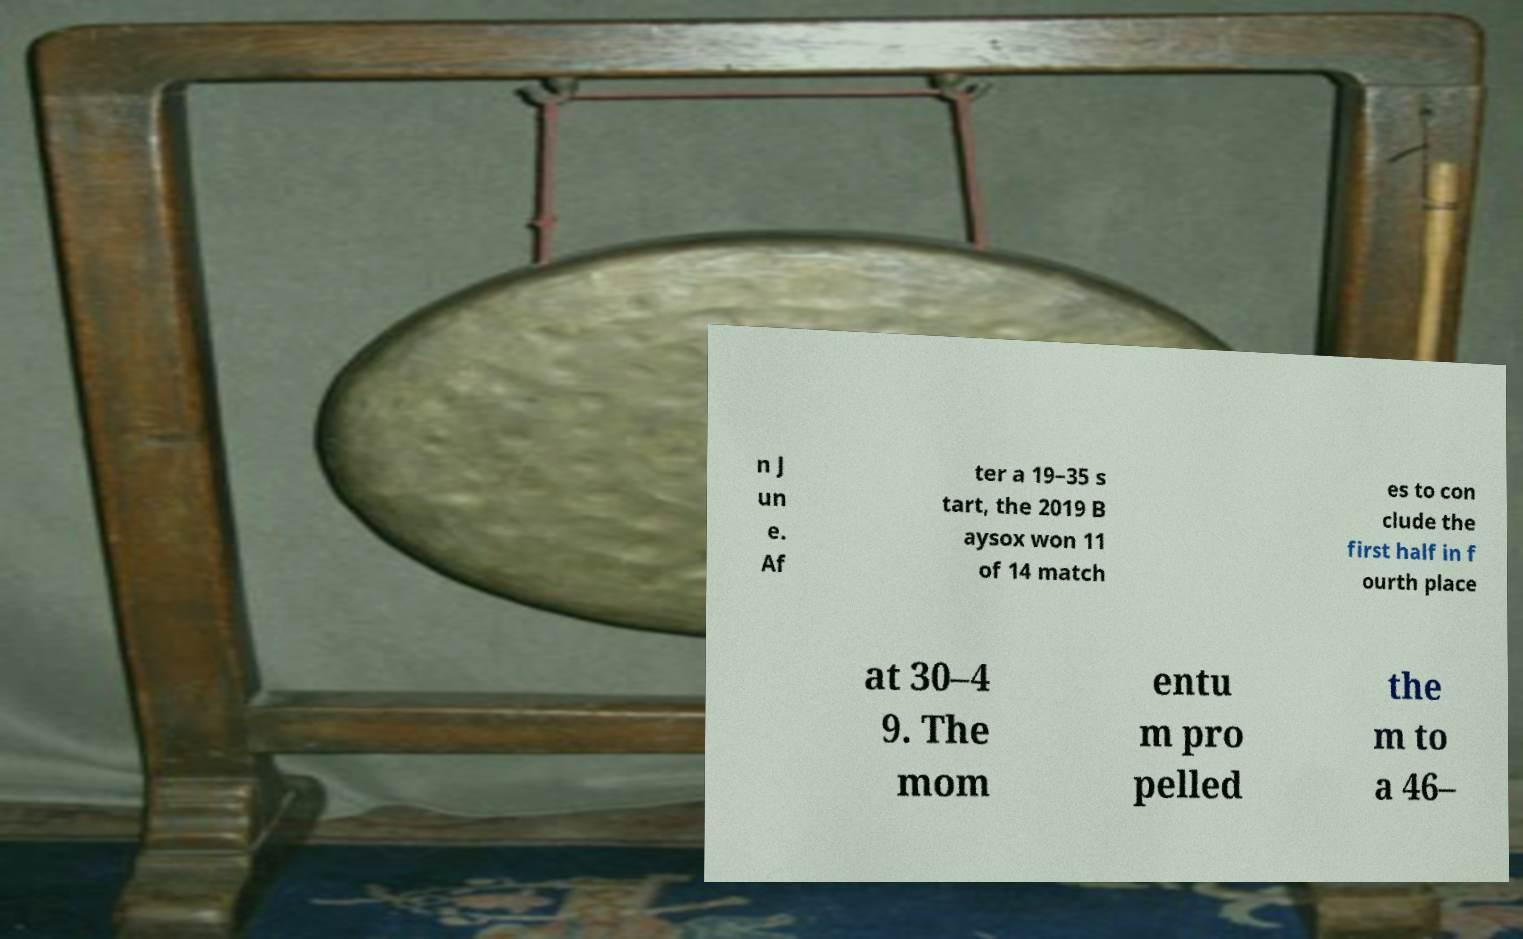For documentation purposes, I need the text within this image transcribed. Could you provide that? n J un e. Af ter a 19–35 s tart, the 2019 B aysox won 11 of 14 match es to con clude the first half in f ourth place at 30–4 9. The mom entu m pro pelled the m to a 46– 